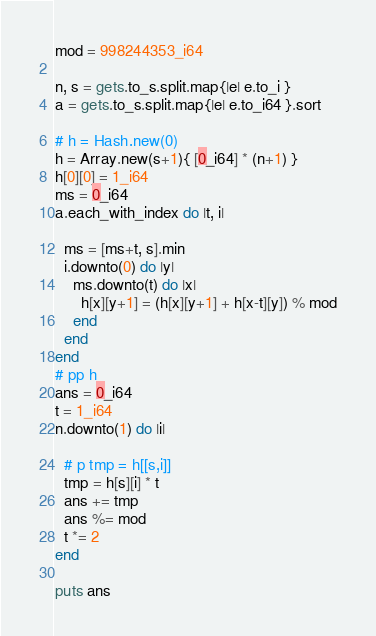<code> <loc_0><loc_0><loc_500><loc_500><_Crystal_>mod = 998244353_i64

n, s = gets.to_s.split.map{|e| e.to_i }
a = gets.to_s.split.map{|e| e.to_i64 }.sort

# h = Hash.new(0)
h = Array.new(s+1){ [0_i64] * (n+1) }
h[0][0] = 1_i64
ms = 0_i64
a.each_with_index do |t, i|
  
  ms = [ms+t, s].min 
  i.downto(0) do |y|
    ms.downto(t) do |x|
      h[x][y+1] = (h[x][y+1] + h[x-t][y]) % mod
    end
  end
end
# pp h
ans = 0_i64
t = 1_i64
n.downto(1) do |i|
  
  # p tmp = h[[s,i]]
  tmp = h[s][i] * t
  ans += tmp
  ans %= mod
  t *= 2
end

puts ans</code> 